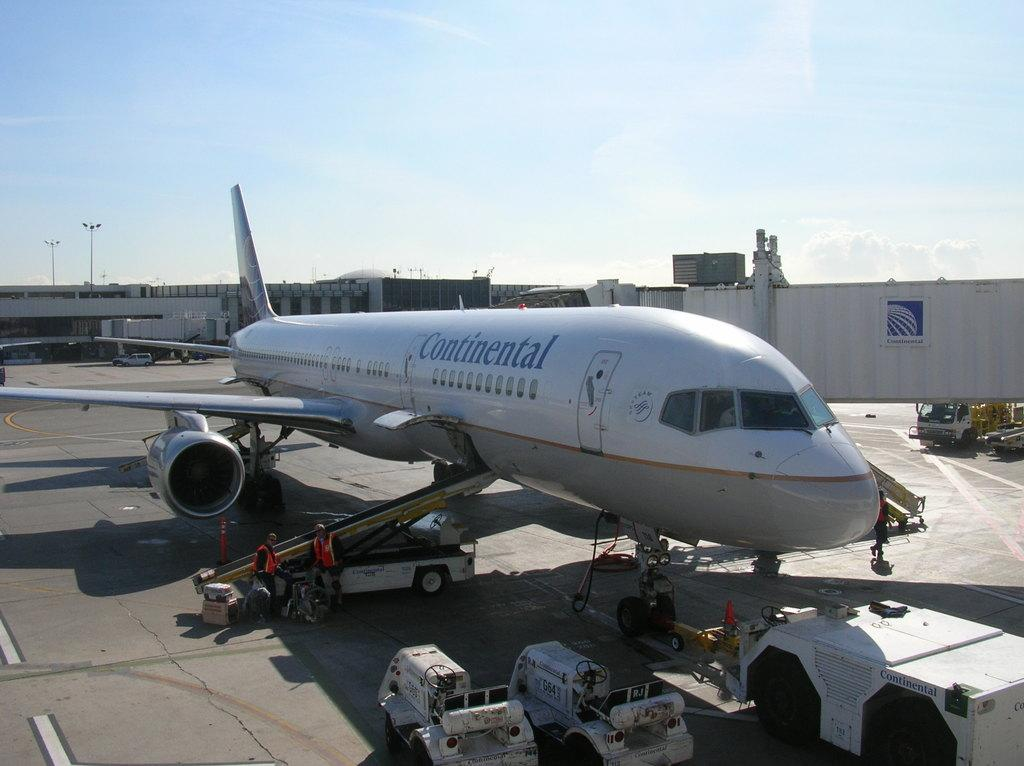<image>
Summarize the visual content of the image. Continental airplane with the logo sky team in blue. 